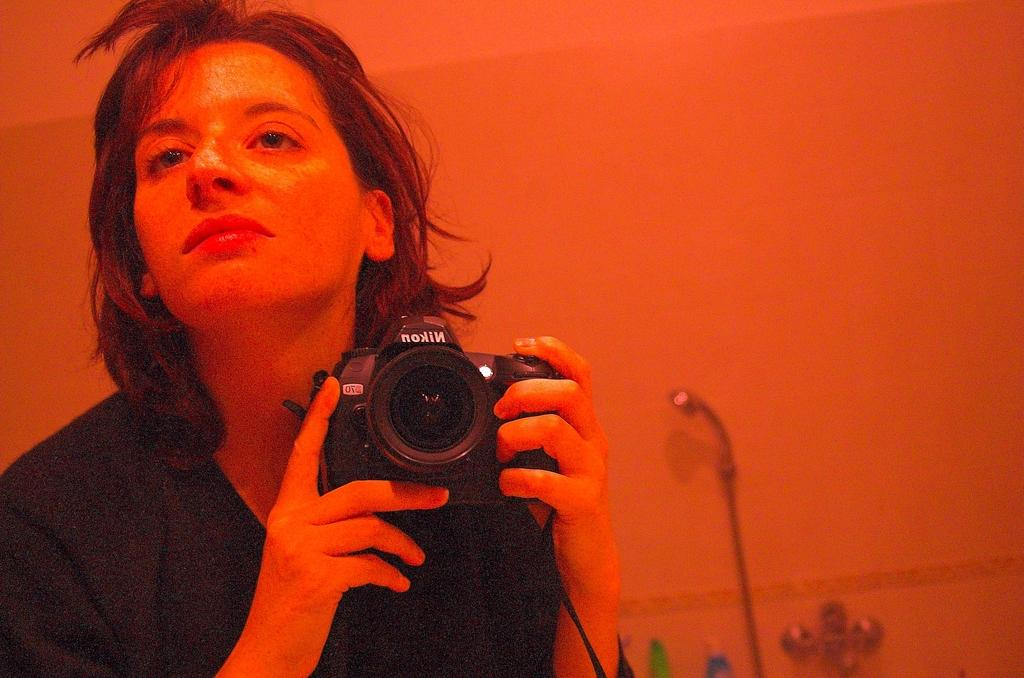What is the main subject of the image? There is a person in the image. What is the person doing in the image? The person is standing. What object is the person holding in their hand? The person is holding a camera in their hand. How would you describe the overall color of the image? The image has a reddish color. Can you see any cobwebs in the image? There are no cobwebs present in the image. What type of ear is the person wearing in the image? The person is not wearing any ear in the image. 